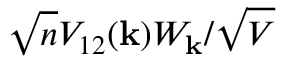Convert formula to latex. <formula><loc_0><loc_0><loc_500><loc_500>\sqrt { n } V _ { 1 2 } ( k ) W _ { k } / \sqrt { V }</formula> 